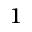<formula> <loc_0><loc_0><loc_500><loc_500>^ { 1 }</formula> 